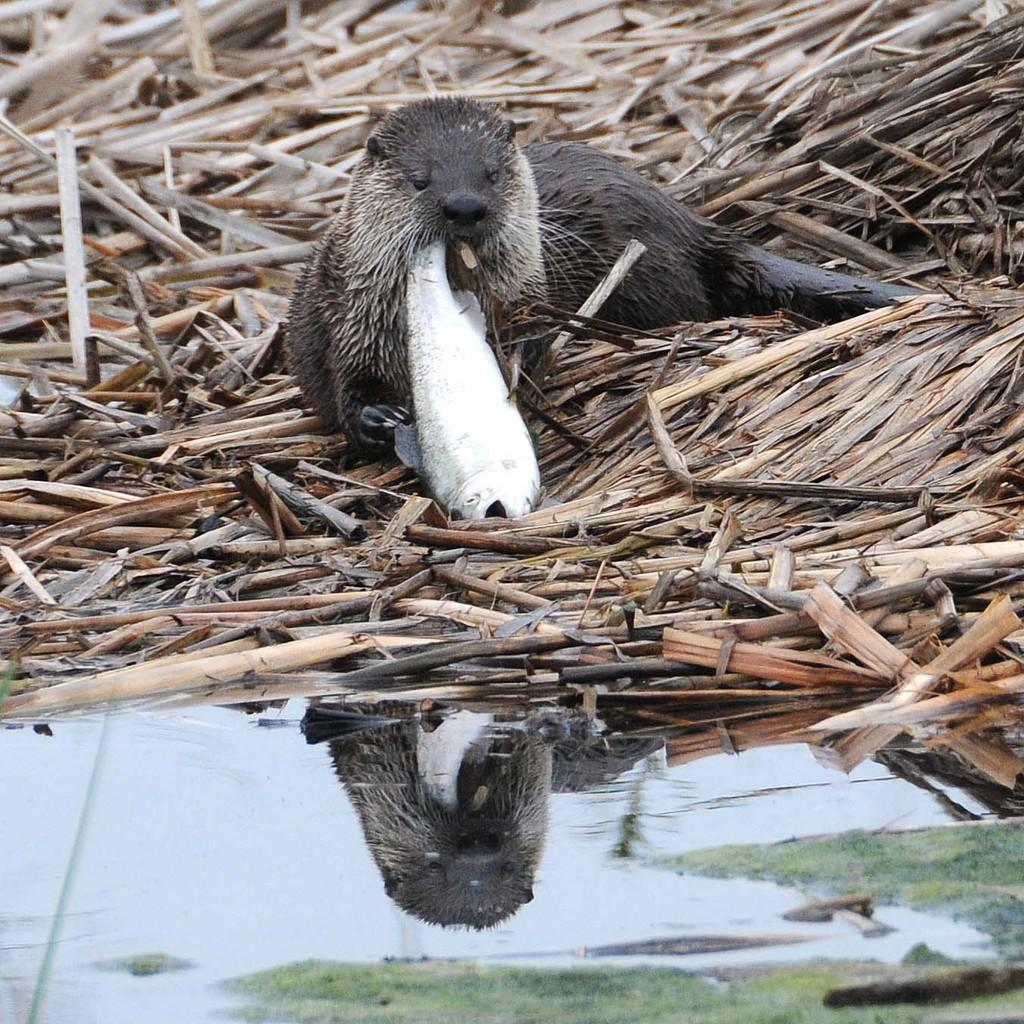What type of animal is in the image? There is an animal in the image, but the specific type cannot be determined from the provided facts. What is the primary element visible in the image? Water is visible in the image. Can you describe any other objects present in the image? There are other objects in the image, but their specific nature cannot be determined from the provided facts. What type of rail can be seen in the image? There is no rail present in the image. What material is the drawer made of in the image? There is no drawer present in the image. 